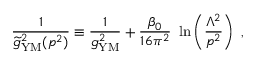<formula> <loc_0><loc_0><loc_500><loc_500>{ \frac { 1 } { { \widetilde { g } } _ { Y M } ^ { 2 } ( p ^ { 2 } ) } } \equiv \frac { 1 } { g _ { Y M } ^ { 2 } } + { \frac { \beta _ { 0 } } { 1 6 \pi ^ { 2 } } } \ln \left ( { \frac { \Lambda ^ { 2 } } { p ^ { 2 } } } \right ) ,</formula> 